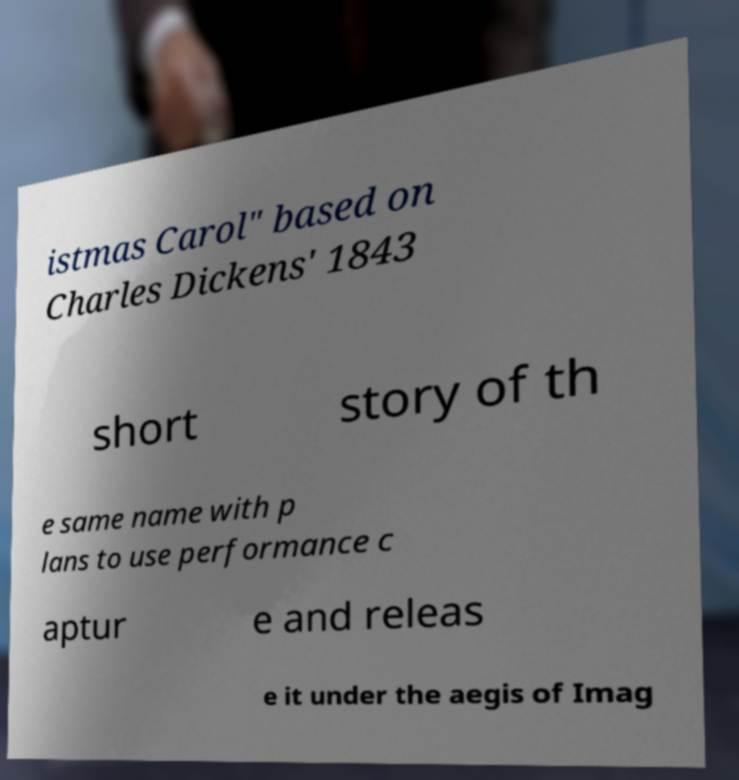What messages or text are displayed in this image? I need them in a readable, typed format. istmas Carol" based on Charles Dickens' 1843 short story of th e same name with p lans to use performance c aptur e and releas e it under the aegis of Imag 